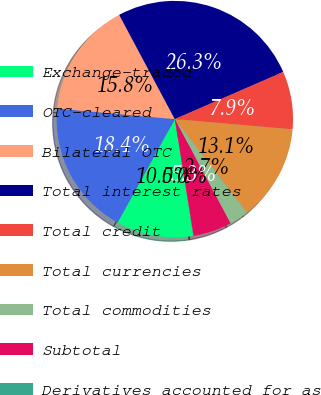Convert chart to OTSL. <chart><loc_0><loc_0><loc_500><loc_500><pie_chart><fcel>Exchange-traded<fcel>OTC-cleared<fcel>Bilateral OTC<fcel>Total interest rates<fcel>Total credit<fcel>Total currencies<fcel>Total commodities<fcel>Subtotal<fcel>Derivatives accounted for as<nl><fcel>10.53%<fcel>18.4%<fcel>15.77%<fcel>26.27%<fcel>7.91%<fcel>13.15%<fcel>2.66%<fcel>5.28%<fcel>0.04%<nl></chart> 